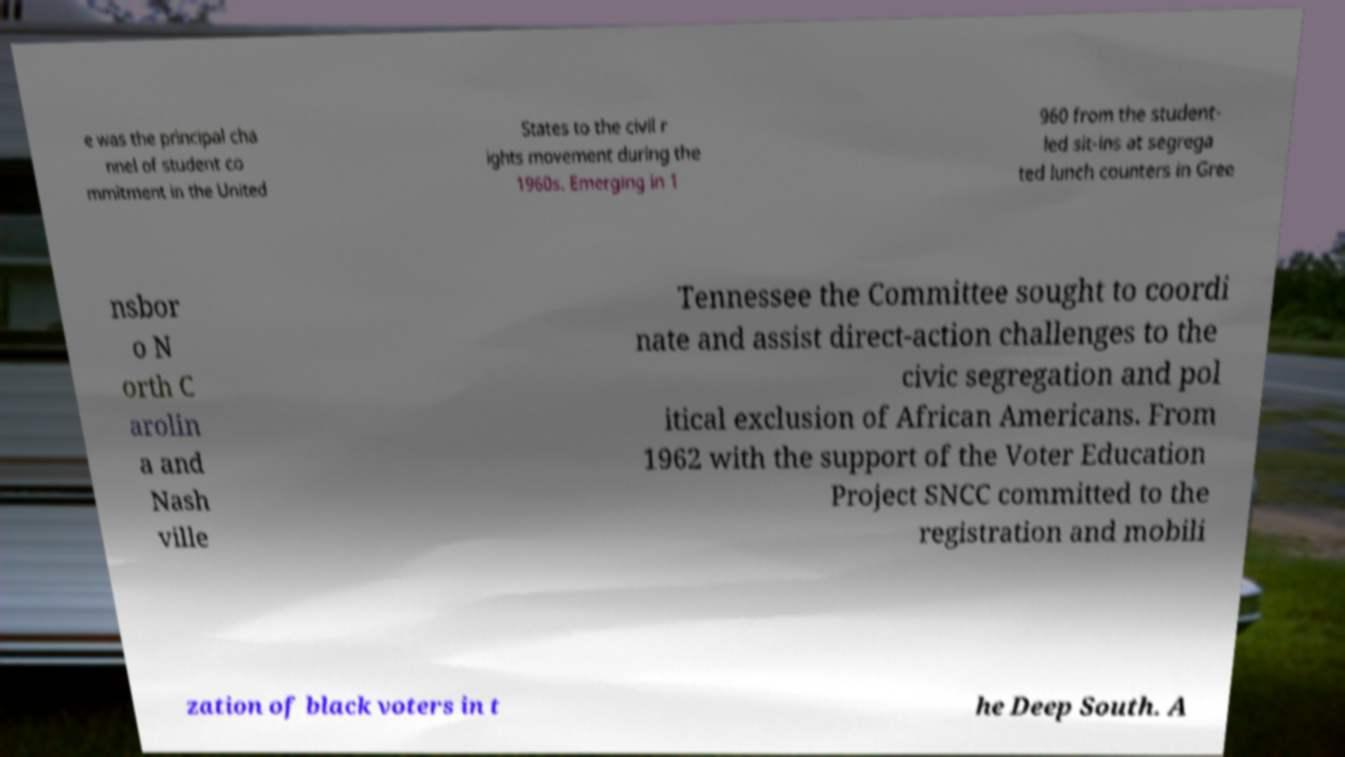Please identify and transcribe the text found in this image. e was the principal cha nnel of student co mmitment in the United States to the civil r ights movement during the 1960s. Emerging in 1 960 from the student- led sit-ins at segrega ted lunch counters in Gree nsbor o N orth C arolin a and Nash ville Tennessee the Committee sought to coordi nate and assist direct-action challenges to the civic segregation and pol itical exclusion of African Americans. From 1962 with the support of the Voter Education Project SNCC committed to the registration and mobili zation of black voters in t he Deep South. A 